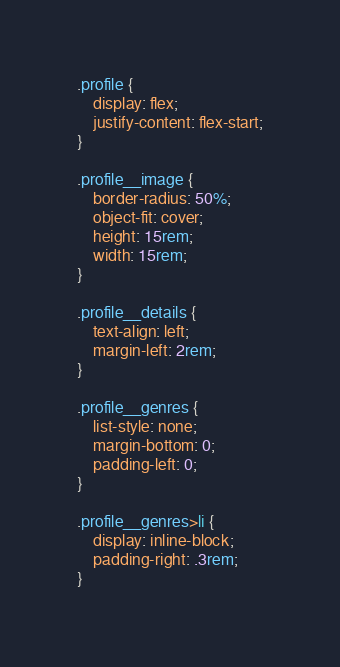Convert code to text. <code><loc_0><loc_0><loc_500><loc_500><_CSS_>.profile {
    display: flex;
    justify-content: flex-start;
}

.profile__image {
    border-radius: 50%;
    object-fit: cover;
    height: 15rem;
    width: 15rem;
}

.profile__details {
    text-align: left;
    margin-left: 2rem;
}

.profile__genres {
    list-style: none;
    margin-bottom: 0;
    padding-left: 0;
}

.profile__genres>li {
    display: inline-block;
    padding-right: .3rem;
}</code> 